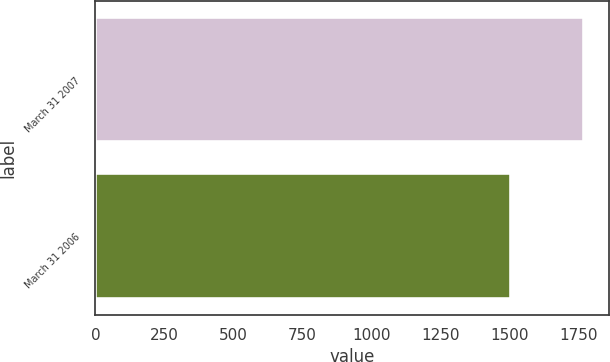Convert chart. <chart><loc_0><loc_0><loc_500><loc_500><bar_chart><fcel>March 31 2007<fcel>March 31 2006<nl><fcel>1770<fcel>1506<nl></chart> 